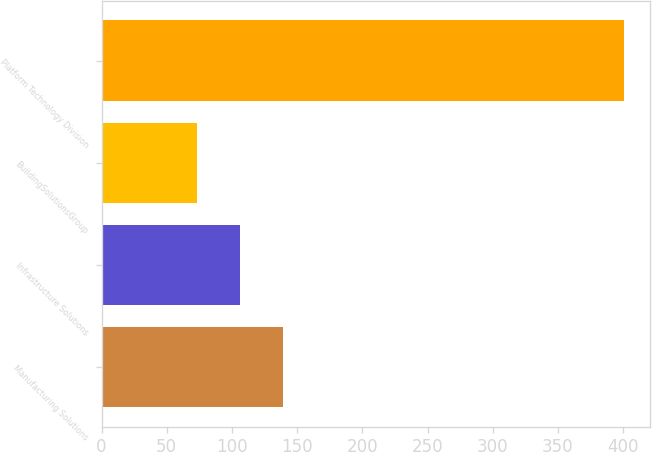Convert chart to OTSL. <chart><loc_0><loc_0><loc_500><loc_500><bar_chart><fcel>Manufacturing Solutions<fcel>Infrastructure Solutions<fcel>BuildingSolutionsGroup<fcel>Platform Technology Division<nl><fcel>138.94<fcel>106.22<fcel>73.5<fcel>400.7<nl></chart> 